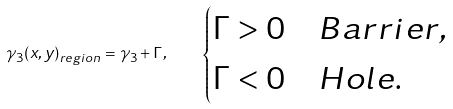<formula> <loc_0><loc_0><loc_500><loc_500>\gamma _ { 3 } ( x , y ) _ { r e g i o n } = \gamma _ { 3 } + \Gamma , \quad \begin{cases} \Gamma > 0 & B a r r i e r , \\ \Gamma < 0 & H o l e . \end{cases}</formula> 